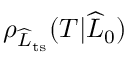Convert formula to latex. <formula><loc_0><loc_0><loc_500><loc_500>\rho _ { \widehat { L } _ { t s } } ( T | \widehat { L } _ { 0 } )</formula> 